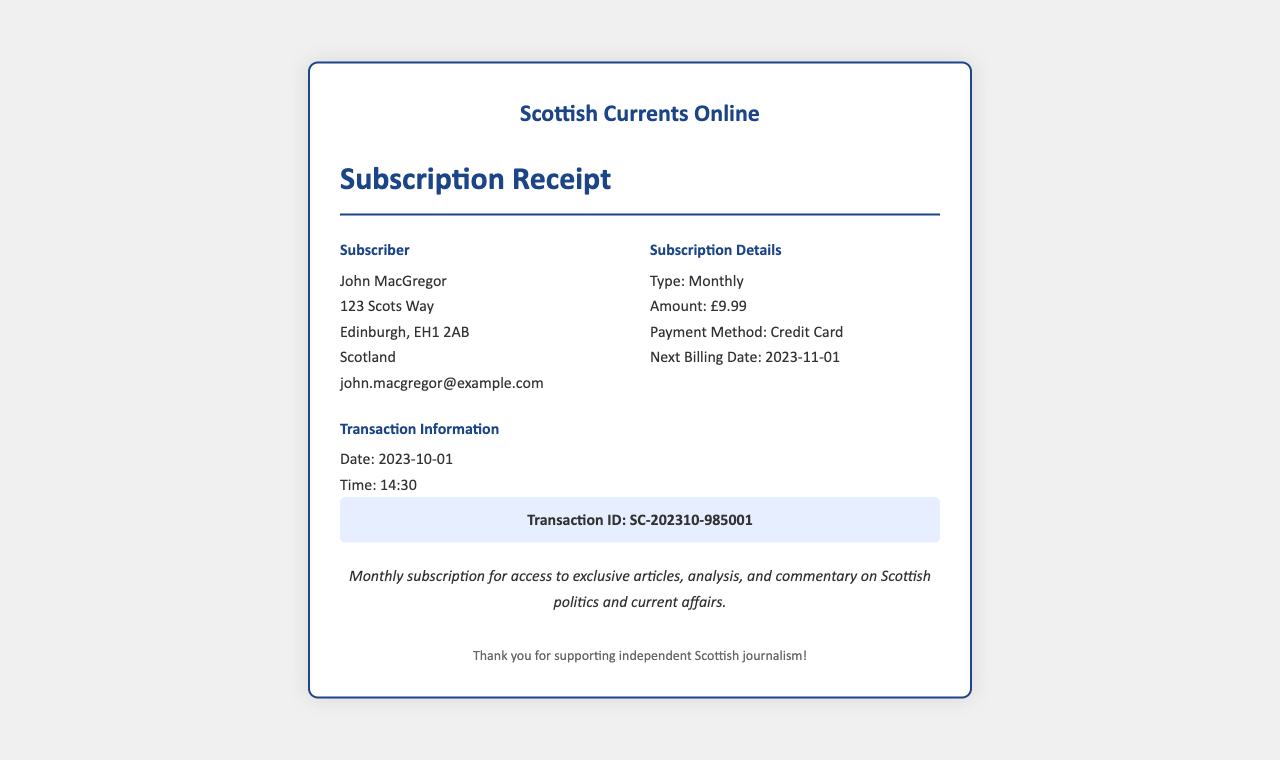What is the subscriber's name? The subscriber's name is specified in the document under the Subscriber section.
Answer: John MacGregor What is the subscription type? The subscription type is mentioned directly in the Subscription Details section of the receipt.
Answer: Monthly What is the amount charged for the subscription? The amount is clearly stated in the Subscription Details section.
Answer: £9.99 What is the payment method used for this subscription? The payment method is listed in the Subscription Details section.
Answer: Credit Card What is the next billing date? The next billing date can be found in the Subscription Details section.
Answer: 2023-11-01 What is the transaction ID? The transaction ID is specified in the Transaction Information section.
Answer: SC-202310-985001 On what date was the transaction made? The transaction date is listed in the Transaction Information section of the receipt.
Answer: 2023-10-01 What is the purpose of the subscription? The purpose can be inferred from the description provided at the bottom of the receipt.
Answer: Access to exclusive articles, analysis, and commentary on Scottish politics and current affairs 